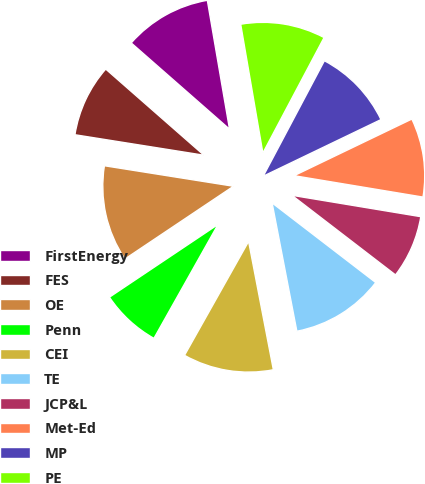<chart> <loc_0><loc_0><loc_500><loc_500><pie_chart><fcel>FirstEnergy<fcel>FES<fcel>OE<fcel>Penn<fcel>CEI<fcel>TE<fcel>JCP&L<fcel>Met-Ed<fcel>MP<fcel>PE<nl><fcel>10.83%<fcel>8.95%<fcel>11.9%<fcel>7.45%<fcel>11.19%<fcel>11.54%<fcel>7.81%<fcel>9.75%<fcel>10.11%<fcel>10.47%<nl></chart> 